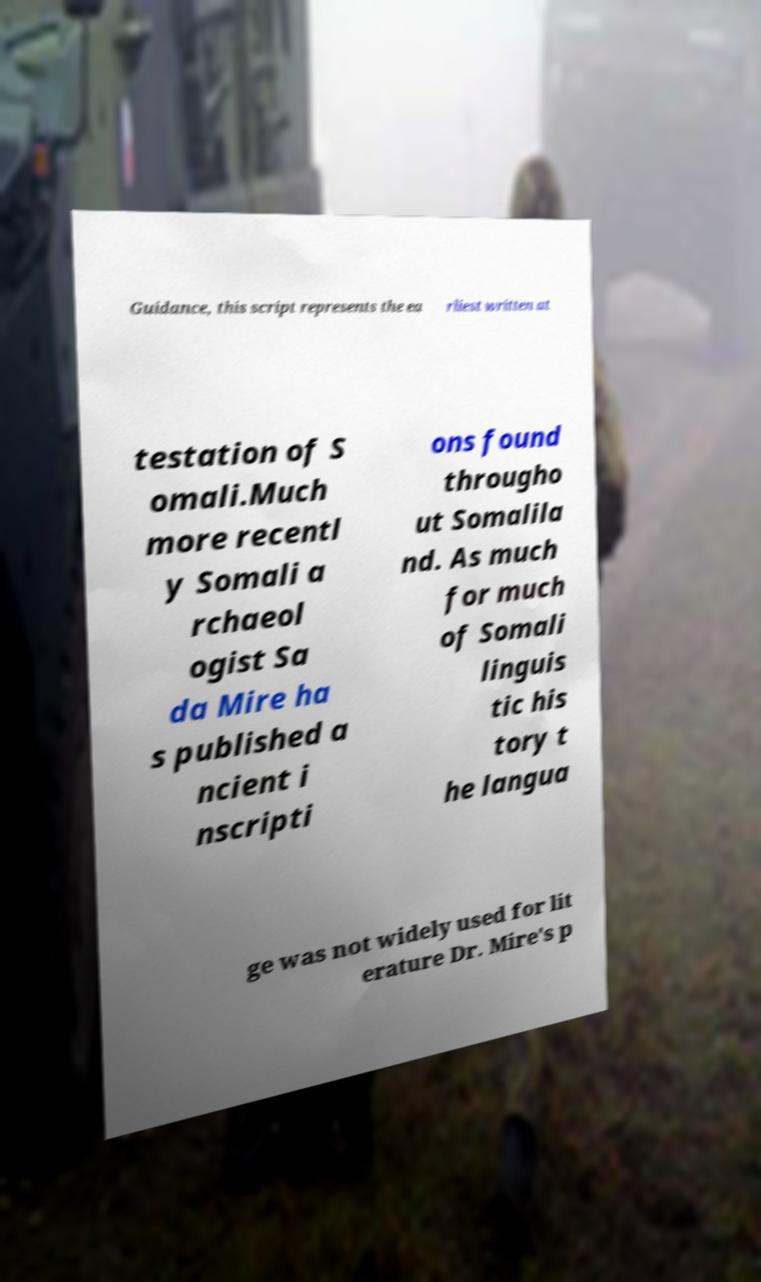Please identify and transcribe the text found in this image. Guidance, this script represents the ea rliest written at testation of S omali.Much more recentl y Somali a rchaeol ogist Sa da Mire ha s published a ncient i nscripti ons found througho ut Somalila nd. As much for much of Somali linguis tic his tory t he langua ge was not widely used for lit erature Dr. Mire's p 